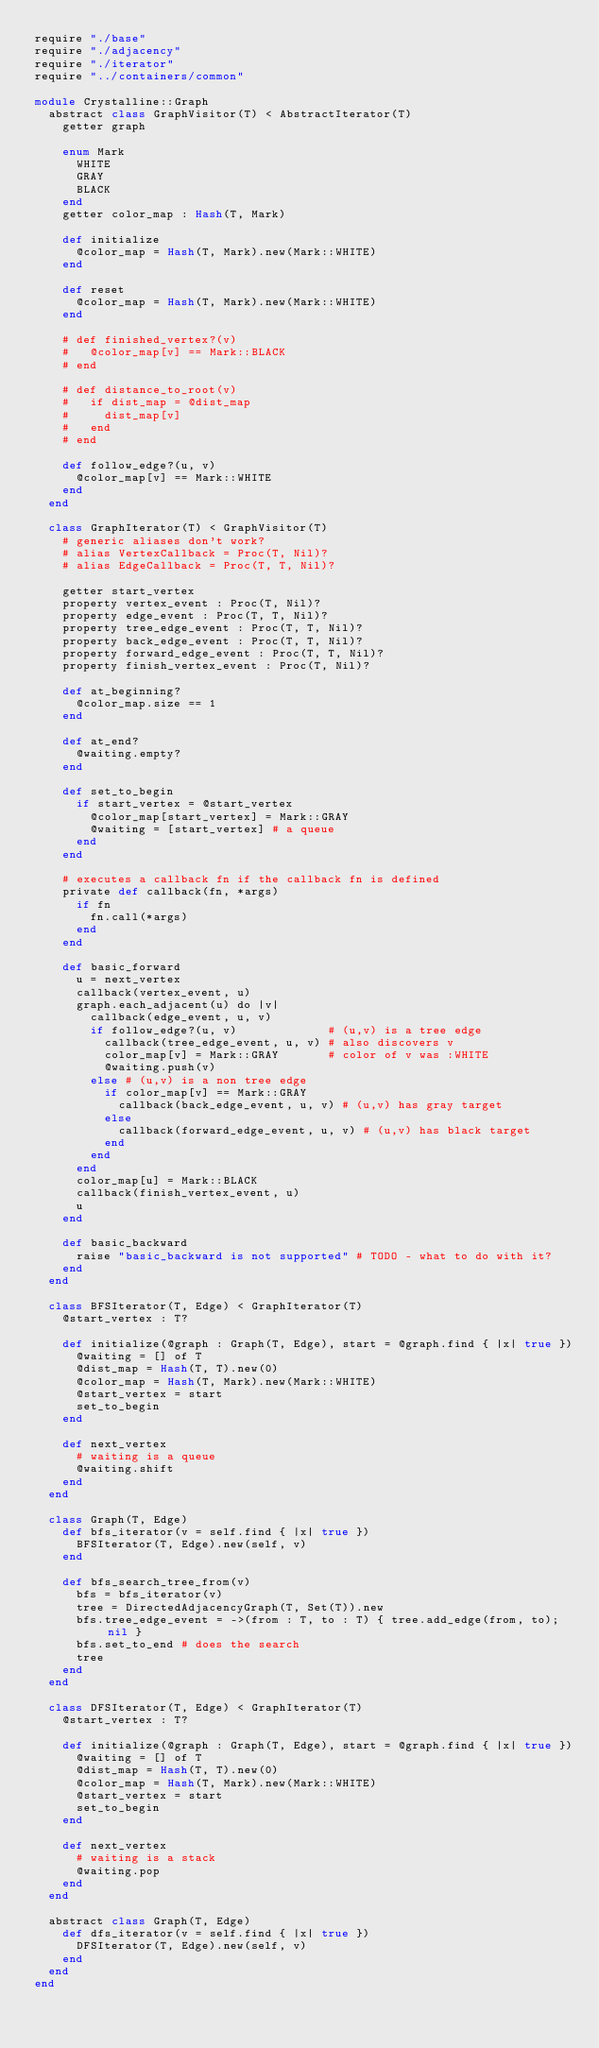Convert code to text. <code><loc_0><loc_0><loc_500><loc_500><_Crystal_>require "./base"
require "./adjacency"
require "./iterator"
require "../containers/common"

module Crystalline::Graph
  abstract class GraphVisitor(T) < AbstractIterator(T)
    getter graph

    enum Mark
      WHITE
      GRAY
      BLACK
    end
    getter color_map : Hash(T, Mark)

    def initialize
      @color_map = Hash(T, Mark).new(Mark::WHITE)
    end

    def reset
      @color_map = Hash(T, Mark).new(Mark::WHITE)
    end

    # def finished_vertex?(v)
    #   @color_map[v] == Mark::BLACK
    # end

    # def distance_to_root(v)
    #   if dist_map = @dist_map
    #     dist_map[v]
    #   end
    # end

    def follow_edge?(u, v)
      @color_map[v] == Mark::WHITE
    end
  end

  class GraphIterator(T) < GraphVisitor(T)
    # generic aliases don't work?
    # alias VertexCallback = Proc(T, Nil)?
    # alias EdgeCallback = Proc(T, T, Nil)?

    getter start_vertex
    property vertex_event : Proc(T, Nil)?
    property edge_event : Proc(T, T, Nil)?
    property tree_edge_event : Proc(T, T, Nil)?
    property back_edge_event : Proc(T, T, Nil)?
    property forward_edge_event : Proc(T, T, Nil)?
    property finish_vertex_event : Proc(T, Nil)?

    def at_beginning?
      @color_map.size == 1
    end

    def at_end?
      @waiting.empty?
    end

    def set_to_begin
      if start_vertex = @start_vertex
        @color_map[start_vertex] = Mark::GRAY
        @waiting = [start_vertex] # a queue
      end
    end

    # executes a callback fn if the callback fn is defined
    private def callback(fn, *args)
      if fn
        fn.call(*args)
      end
    end

    def basic_forward
      u = next_vertex
      callback(vertex_event, u)
      graph.each_adjacent(u) do |v|
        callback(edge_event, u, v)
        if follow_edge?(u, v)             # (u,v) is a tree edge
          callback(tree_edge_event, u, v) # also discovers v
          color_map[v] = Mark::GRAY       # color of v was :WHITE
          @waiting.push(v)
        else # (u,v) is a non tree edge
          if color_map[v] == Mark::GRAY
            callback(back_edge_event, u, v) # (u,v) has gray target
          else
            callback(forward_edge_event, u, v) # (u,v) has black target
          end
        end
      end
      color_map[u] = Mark::BLACK
      callback(finish_vertex_event, u)
      u
    end

    def basic_backward
      raise "basic_backward is not supported" # TODO - what to do with it?
    end
  end

  class BFSIterator(T, Edge) < GraphIterator(T)
    @start_vertex : T?

    def initialize(@graph : Graph(T, Edge), start = @graph.find { |x| true })
      @waiting = [] of T
      @dist_map = Hash(T, T).new(0)
      @color_map = Hash(T, Mark).new(Mark::WHITE)
      @start_vertex = start
      set_to_begin
    end

    def next_vertex
      # waiting is a queue
      @waiting.shift
    end
  end

  class Graph(T, Edge)
    def bfs_iterator(v = self.find { |x| true })
      BFSIterator(T, Edge).new(self, v)
    end

    def bfs_search_tree_from(v)
      bfs = bfs_iterator(v)
      tree = DirectedAdjacencyGraph(T, Set(T)).new
      bfs.tree_edge_event = ->(from : T, to : T) { tree.add_edge(from, to); nil }
      bfs.set_to_end # does the search
      tree
    end
  end

  class DFSIterator(T, Edge) < GraphIterator(T)
    @start_vertex : T?

    def initialize(@graph : Graph(T, Edge), start = @graph.find { |x| true })
      @waiting = [] of T
      @dist_map = Hash(T, T).new(0)
      @color_map = Hash(T, Mark).new(Mark::WHITE)
      @start_vertex = start
      set_to_begin
    end

    def next_vertex
      # waiting is a stack
      @waiting.pop
    end
  end

  abstract class Graph(T, Edge)
    def dfs_iterator(v = self.find { |x| true })
      DFSIterator(T, Edge).new(self, v)
    end
  end
end
</code> 